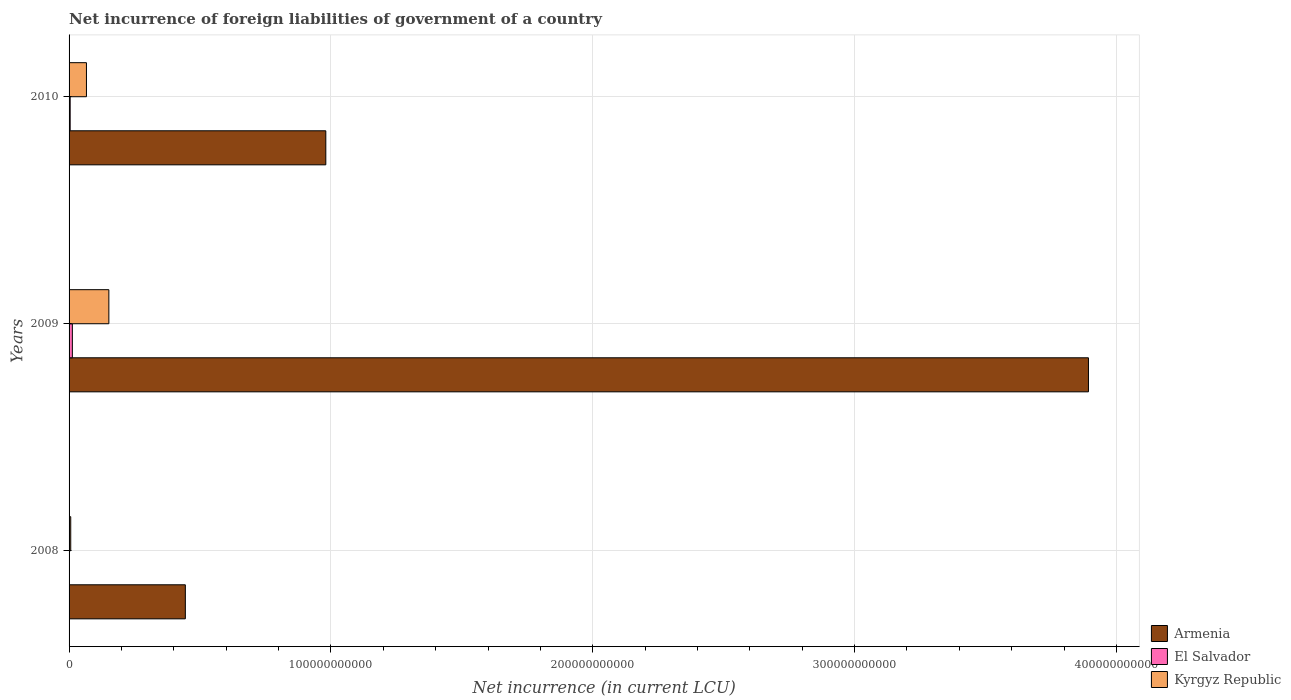Are the number of bars on each tick of the Y-axis equal?
Provide a succinct answer. No. How many bars are there on the 3rd tick from the top?
Give a very brief answer. 2. What is the net incurrence of foreign liabilities in Kyrgyz Republic in 2010?
Keep it short and to the point. 6.64e+09. Across all years, what is the maximum net incurrence of foreign liabilities in Armenia?
Make the answer very short. 3.89e+11. In which year was the net incurrence of foreign liabilities in Armenia maximum?
Offer a very short reply. 2009. What is the total net incurrence of foreign liabilities in Armenia in the graph?
Provide a short and direct response. 5.32e+11. What is the difference between the net incurrence of foreign liabilities in Armenia in 2009 and that in 2010?
Your response must be concise. 2.91e+11. What is the difference between the net incurrence of foreign liabilities in Armenia in 2010 and the net incurrence of foreign liabilities in El Salvador in 2009?
Your response must be concise. 9.68e+1. What is the average net incurrence of foreign liabilities in Kyrgyz Republic per year?
Offer a very short reply. 7.49e+09. In the year 2010, what is the difference between the net incurrence of foreign liabilities in El Salvador and net incurrence of foreign liabilities in Kyrgyz Republic?
Your answer should be compact. -6.22e+09. What is the ratio of the net incurrence of foreign liabilities in Kyrgyz Republic in 2008 to that in 2009?
Provide a short and direct response. 0.04. What is the difference between the highest and the second highest net incurrence of foreign liabilities in Kyrgyz Republic?
Offer a terse response. 8.56e+09. What is the difference between the highest and the lowest net incurrence of foreign liabilities in El Salvador?
Your response must be concise. 1.25e+09. In how many years, is the net incurrence of foreign liabilities in El Salvador greater than the average net incurrence of foreign liabilities in El Salvador taken over all years?
Offer a very short reply. 1. Is the sum of the net incurrence of foreign liabilities in Armenia in 2008 and 2010 greater than the maximum net incurrence of foreign liabilities in Kyrgyz Republic across all years?
Your response must be concise. Yes. How many bars are there?
Give a very brief answer. 8. Are all the bars in the graph horizontal?
Keep it short and to the point. Yes. How many years are there in the graph?
Give a very brief answer. 3. What is the difference between two consecutive major ticks on the X-axis?
Offer a very short reply. 1.00e+11. Are the values on the major ticks of X-axis written in scientific E-notation?
Your answer should be compact. No. Does the graph contain grids?
Offer a very short reply. Yes. How many legend labels are there?
Give a very brief answer. 3. What is the title of the graph?
Your response must be concise. Net incurrence of foreign liabilities of government of a country. Does "Namibia" appear as one of the legend labels in the graph?
Your answer should be very brief. No. What is the label or title of the X-axis?
Your answer should be very brief. Net incurrence (in current LCU). What is the Net incurrence (in current LCU) in Armenia in 2008?
Offer a very short reply. 4.44e+1. What is the Net incurrence (in current LCU) in Kyrgyz Republic in 2008?
Keep it short and to the point. 6.33e+08. What is the Net incurrence (in current LCU) in Armenia in 2009?
Keep it short and to the point. 3.89e+11. What is the Net incurrence (in current LCU) of El Salvador in 2009?
Keep it short and to the point. 1.25e+09. What is the Net incurrence (in current LCU) of Kyrgyz Republic in 2009?
Provide a succinct answer. 1.52e+1. What is the Net incurrence (in current LCU) in Armenia in 2010?
Ensure brevity in your answer.  9.81e+1. What is the Net incurrence (in current LCU) of El Salvador in 2010?
Make the answer very short. 4.21e+08. What is the Net incurrence (in current LCU) in Kyrgyz Republic in 2010?
Your response must be concise. 6.64e+09. Across all years, what is the maximum Net incurrence (in current LCU) in Armenia?
Provide a succinct answer. 3.89e+11. Across all years, what is the maximum Net incurrence (in current LCU) of El Salvador?
Provide a succinct answer. 1.25e+09. Across all years, what is the maximum Net incurrence (in current LCU) of Kyrgyz Republic?
Offer a very short reply. 1.52e+1. Across all years, what is the minimum Net incurrence (in current LCU) in Armenia?
Provide a short and direct response. 4.44e+1. Across all years, what is the minimum Net incurrence (in current LCU) of El Salvador?
Provide a short and direct response. 0. Across all years, what is the minimum Net incurrence (in current LCU) of Kyrgyz Republic?
Offer a terse response. 6.33e+08. What is the total Net incurrence (in current LCU) in Armenia in the graph?
Offer a very short reply. 5.32e+11. What is the total Net incurrence (in current LCU) of El Salvador in the graph?
Keep it short and to the point. 1.68e+09. What is the total Net incurrence (in current LCU) in Kyrgyz Republic in the graph?
Provide a succinct answer. 2.25e+1. What is the difference between the Net incurrence (in current LCU) in Armenia in 2008 and that in 2009?
Your answer should be very brief. -3.45e+11. What is the difference between the Net incurrence (in current LCU) in Kyrgyz Republic in 2008 and that in 2009?
Provide a succinct answer. -1.46e+1. What is the difference between the Net incurrence (in current LCU) of Armenia in 2008 and that in 2010?
Your answer should be compact. -5.36e+1. What is the difference between the Net incurrence (in current LCU) in Kyrgyz Republic in 2008 and that in 2010?
Your answer should be compact. -6.01e+09. What is the difference between the Net incurrence (in current LCU) of Armenia in 2009 and that in 2010?
Make the answer very short. 2.91e+11. What is the difference between the Net incurrence (in current LCU) in El Salvador in 2009 and that in 2010?
Your answer should be very brief. 8.34e+08. What is the difference between the Net incurrence (in current LCU) of Kyrgyz Republic in 2009 and that in 2010?
Offer a terse response. 8.56e+09. What is the difference between the Net incurrence (in current LCU) of Armenia in 2008 and the Net incurrence (in current LCU) of El Salvador in 2009?
Give a very brief answer. 4.32e+1. What is the difference between the Net incurrence (in current LCU) of Armenia in 2008 and the Net incurrence (in current LCU) of Kyrgyz Republic in 2009?
Offer a very short reply. 2.92e+1. What is the difference between the Net incurrence (in current LCU) in Armenia in 2008 and the Net incurrence (in current LCU) in El Salvador in 2010?
Keep it short and to the point. 4.40e+1. What is the difference between the Net incurrence (in current LCU) in Armenia in 2008 and the Net incurrence (in current LCU) in Kyrgyz Republic in 2010?
Give a very brief answer. 3.78e+1. What is the difference between the Net incurrence (in current LCU) of Armenia in 2009 and the Net incurrence (in current LCU) of El Salvador in 2010?
Give a very brief answer. 3.89e+11. What is the difference between the Net incurrence (in current LCU) in Armenia in 2009 and the Net incurrence (in current LCU) in Kyrgyz Republic in 2010?
Give a very brief answer. 3.83e+11. What is the difference between the Net incurrence (in current LCU) in El Salvador in 2009 and the Net incurrence (in current LCU) in Kyrgyz Republic in 2010?
Your answer should be compact. -5.38e+09. What is the average Net incurrence (in current LCU) of Armenia per year?
Offer a very short reply. 1.77e+11. What is the average Net incurrence (in current LCU) of El Salvador per year?
Provide a succinct answer. 5.59e+08. What is the average Net incurrence (in current LCU) in Kyrgyz Republic per year?
Offer a very short reply. 7.49e+09. In the year 2008, what is the difference between the Net incurrence (in current LCU) of Armenia and Net incurrence (in current LCU) of Kyrgyz Republic?
Provide a succinct answer. 4.38e+1. In the year 2009, what is the difference between the Net incurrence (in current LCU) of Armenia and Net incurrence (in current LCU) of El Salvador?
Make the answer very short. 3.88e+11. In the year 2009, what is the difference between the Net incurrence (in current LCU) in Armenia and Net incurrence (in current LCU) in Kyrgyz Republic?
Keep it short and to the point. 3.74e+11. In the year 2009, what is the difference between the Net incurrence (in current LCU) of El Salvador and Net incurrence (in current LCU) of Kyrgyz Republic?
Your response must be concise. -1.39e+1. In the year 2010, what is the difference between the Net incurrence (in current LCU) in Armenia and Net incurrence (in current LCU) in El Salvador?
Your answer should be very brief. 9.76e+1. In the year 2010, what is the difference between the Net incurrence (in current LCU) in Armenia and Net incurrence (in current LCU) in Kyrgyz Republic?
Your answer should be very brief. 9.14e+1. In the year 2010, what is the difference between the Net incurrence (in current LCU) in El Salvador and Net incurrence (in current LCU) in Kyrgyz Republic?
Your response must be concise. -6.22e+09. What is the ratio of the Net incurrence (in current LCU) in Armenia in 2008 to that in 2009?
Your answer should be compact. 0.11. What is the ratio of the Net incurrence (in current LCU) in Kyrgyz Republic in 2008 to that in 2009?
Your answer should be compact. 0.04. What is the ratio of the Net incurrence (in current LCU) of Armenia in 2008 to that in 2010?
Keep it short and to the point. 0.45. What is the ratio of the Net incurrence (in current LCU) in Kyrgyz Republic in 2008 to that in 2010?
Make the answer very short. 0.1. What is the ratio of the Net incurrence (in current LCU) of Armenia in 2009 to that in 2010?
Make the answer very short. 3.97. What is the ratio of the Net incurrence (in current LCU) of El Salvador in 2009 to that in 2010?
Your answer should be very brief. 2.98. What is the ratio of the Net incurrence (in current LCU) of Kyrgyz Republic in 2009 to that in 2010?
Your answer should be very brief. 2.29. What is the difference between the highest and the second highest Net incurrence (in current LCU) of Armenia?
Make the answer very short. 2.91e+11. What is the difference between the highest and the second highest Net incurrence (in current LCU) of Kyrgyz Republic?
Your answer should be compact. 8.56e+09. What is the difference between the highest and the lowest Net incurrence (in current LCU) of Armenia?
Offer a very short reply. 3.45e+11. What is the difference between the highest and the lowest Net incurrence (in current LCU) of El Salvador?
Your answer should be compact. 1.25e+09. What is the difference between the highest and the lowest Net incurrence (in current LCU) in Kyrgyz Republic?
Provide a succinct answer. 1.46e+1. 